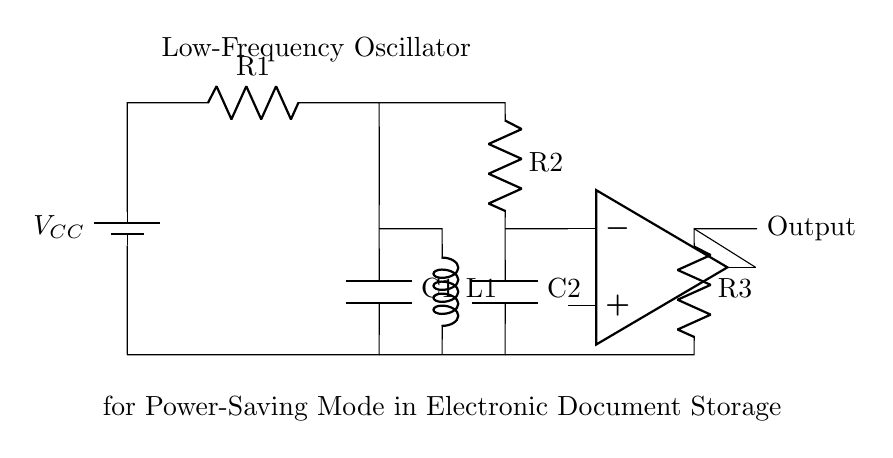What is the power supply voltage labeled in the circuit? The circuit contains a component labeled as a battery with voltage notation of V subscript CC, which represents the power supply voltage.
Answer: V CC What is the total number of resistors in the circuit? By examining the circuit diagram, I identify three resistors labeled R1, R2, and R3, indicating that there are three resistors in total.
Answer: 3 Which component serves as the output for this oscillator? The output node is directly indicated by the label "Output" on the circuit, which shows that it is connected to a specific point in the oscillator circuit.
Answer: Output What types of components are labeled as C1 and C2? The components labeled C1 and C2 are capacitors, which can be identified by their conventional symbol in the circuit diagram.
Answer: Capacitors How does the inductor's position affect the oscillator's frequency output? The inductor's placement in the circuit influences the resonant circuit behavior, specifically the oscillation frequency, as it interacts with the capacitors and resistors, establishing a specific frequency according to the LC circuit formula.
Answer: It alters frequency What is the function of the operational amplifier in this circuit? The operational amplifier (op-amp) is utilized to amplify the signal within the oscillator circuit, enhancing the output signal's strength, which is critical for low-frequency oscillation.
Answer: Signal amplification What is the main purpose of this low-frequency oscillator? The primary purpose of the low-frequency oscillator illustrated in the circuit is to facilitate power-saving modes in electronic document storage devices by generating oscillation patterns at lower frequencies.
Answer: Power-saving mode 